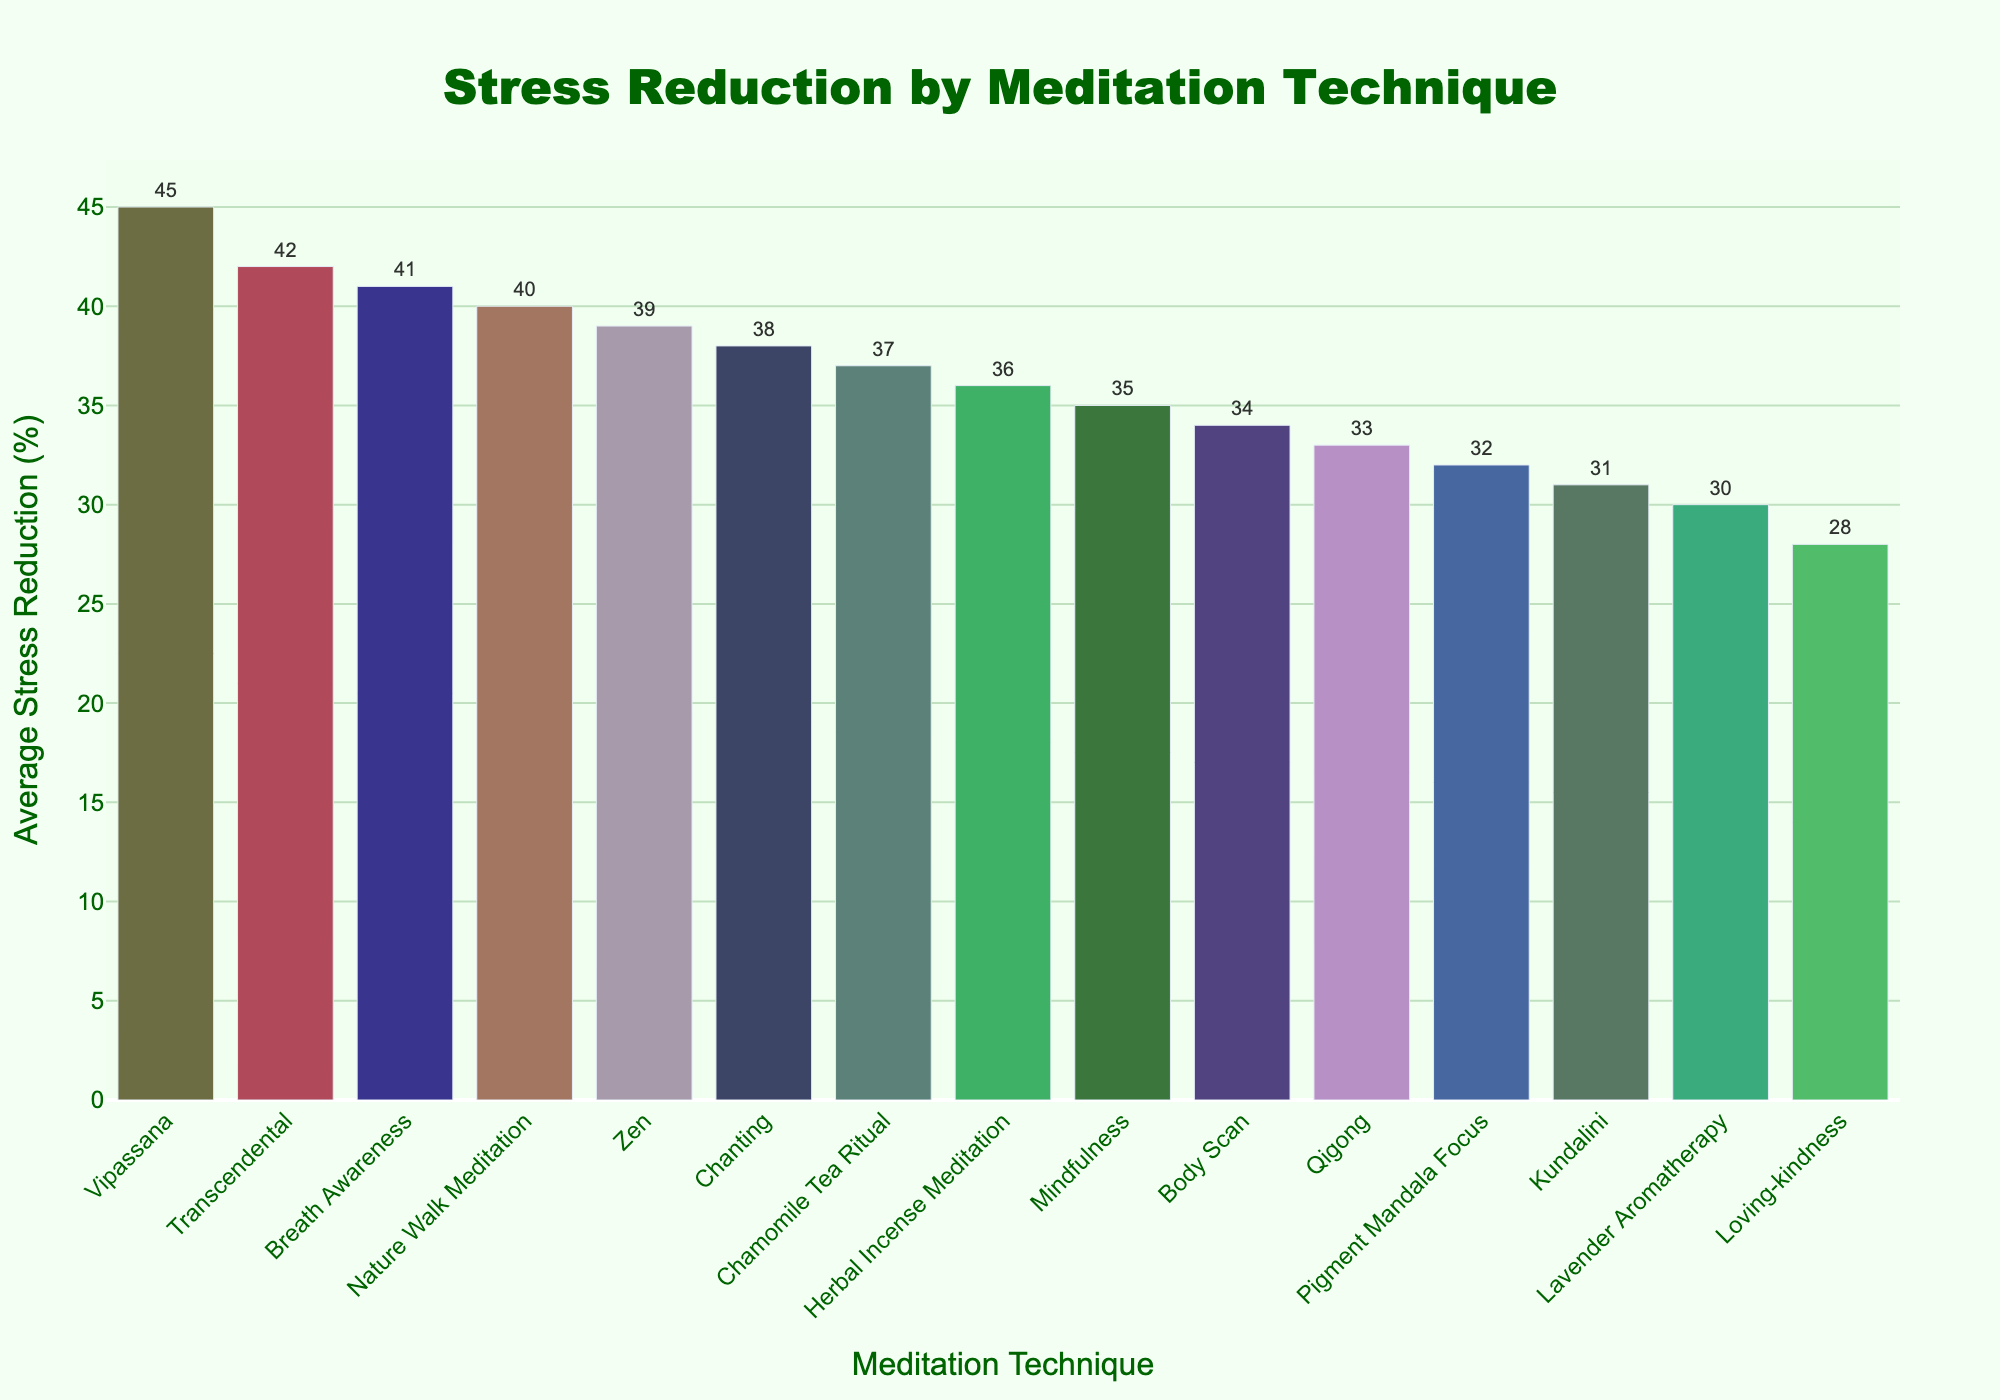Which meditation technique has the highest average stress reduction? By looking at the figure, identify the bar with the highest value for stress reduction. The technique with the highest bar represents the highest average stress reduction.
Answer: Vipassana Which meditation technique has the lowest average stress reduction? By looking at the figure, identify the bar with the lowest value for stress reduction. The technique with the lowest bar represents the lowest average stress reduction.
Answer: Loving-kindness How much higher is the average stress reduction of Vipassana compared to Lavender Aromatherapy? First, identify the values for both techniques from the figure: Vipassana is 45%, and Lavender Aromatherapy is 30%. Subtract the lower value from the higher one: 45 - 30 = 15%.
Answer: 15% Which techniques have an average stress reduction between 30% and 40%? Scan the bars in the figure to find those with values between 30% and 40%. List those techniques that fall within this range.
Answer: Mindfulness, Loving-kindness, Zen, Kundalini, Qigong, Chamomile Tea Ritual, Lavender Aromatherapy, Herbal Incense Meditation, Pigment Mandala Focus, Chanting, Body Scan What is the difference between the stress reduction percentage of Nature Walk Meditation and Body Scan? Identify and compare the values from the figure: Nature Walk Meditation is 40%, and Body Scan is 34%. Subtract the smaller value from the larger one: 40 - 34 = 6%.
Answer: 6% Which technique is visually represented by the tallest bar? Look for the bar that extends the highest in the figure. The tallest bar corresponds to the technique with the highest average stress reduction.
Answer: Vipassana List the techniques that have an average stress reduction above 40%. Examine the figure and identify the bars representing techniques with values greater than 40%. List these techniques.
Answer: Vipassana, Breath Awareness, Transcendental Compare the stress reduction of Mindfulness to Zen. Which one is higher and by how much? Find the values for both techniques: Mindfulness is 35%, and Zen is 39%. Zen is higher. To find the difference, subtract the lower value from the higher one: 39 - 35 = 4%.
Answer: Zen by 4% Which two techniques have the closest average stress reduction percentages? Compare the values for each technique and find the pair with the smallest difference between their percentages.
Answer: Mindfulness (35%) and Herbal Incense Meditation (36%) What is the combined average stress reduction percentage of Transcendental and Breath Awareness techniques? Find the values for both techniques from the figure: Transcendental is 42%, and Breath Awareness is 41%. Add the two percentages together: 42 + 41 = 83%.
Answer: 83% 